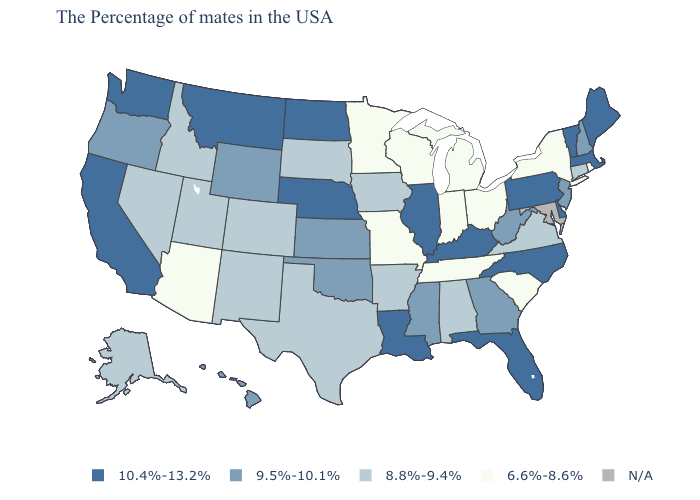Does Massachusetts have the lowest value in the Northeast?
Concise answer only. No. What is the value of Idaho?
Give a very brief answer. 8.8%-9.4%. Which states have the lowest value in the South?
Concise answer only. South Carolina, Tennessee. What is the value of Kansas?
Keep it brief. 9.5%-10.1%. Among the states that border Texas , which have the lowest value?
Concise answer only. Arkansas, New Mexico. What is the highest value in states that border Pennsylvania?
Be succinct. 10.4%-13.2%. How many symbols are there in the legend?
Quick response, please. 5. Does the map have missing data?
Give a very brief answer. Yes. Does the first symbol in the legend represent the smallest category?
Keep it brief. No. Which states hav the highest value in the Northeast?
Give a very brief answer. Maine, Massachusetts, Vermont, Pennsylvania. What is the value of Kentucky?
Short answer required. 10.4%-13.2%. Does Minnesota have the lowest value in the USA?
Concise answer only. Yes. What is the value of Maine?
Short answer required. 10.4%-13.2%. Which states have the lowest value in the USA?
Quick response, please. Rhode Island, New York, South Carolina, Ohio, Michigan, Indiana, Tennessee, Wisconsin, Missouri, Minnesota, Arizona. What is the value of Tennessee?
Concise answer only. 6.6%-8.6%. 